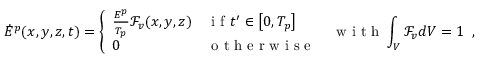Convert formula to latex. <formula><loc_0><loc_0><loc_500><loc_500>\dot { E } ^ { p } ( x , y , z , t ) = \left \{ \begin{array} { l l } { \frac { E ^ { p } } { T _ { p } } \mathcal { F } _ { v } ( x , y , z ) } & { i f t ^ { \prime } \in \left [ 0 , T _ { p } \right ] } \\ { 0 } & { o t h e r w i s e } \end{array} \, w i t h \int _ { V } \mathcal { F } _ { v } d V = 1 \, ,</formula> 